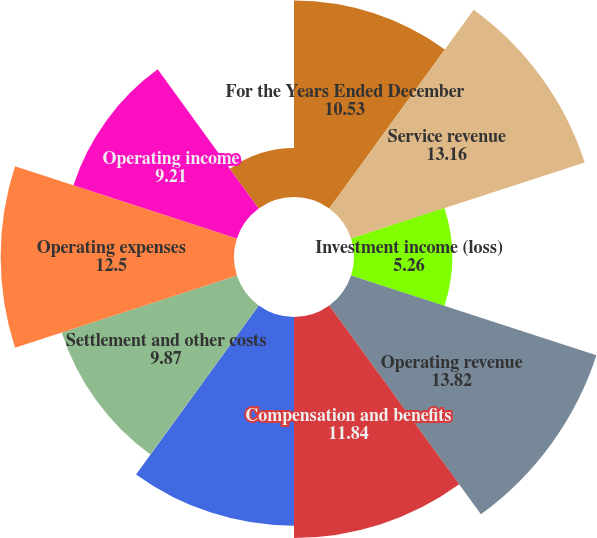Convert chart to OTSL. <chart><loc_0><loc_0><loc_500><loc_500><pie_chart><fcel>For the Years Ended December<fcel>Service revenue<fcel>Investment income (loss)<fcel>Operating revenue<fcel>Compensation and benefits<fcel>Other operating expenses<fcel>Settlement and other costs<fcel>Operating expenses<fcel>Operating income<fcel>Interest income<nl><fcel>10.53%<fcel>13.16%<fcel>5.26%<fcel>13.82%<fcel>11.84%<fcel>11.18%<fcel>9.87%<fcel>12.5%<fcel>9.21%<fcel>2.63%<nl></chart> 